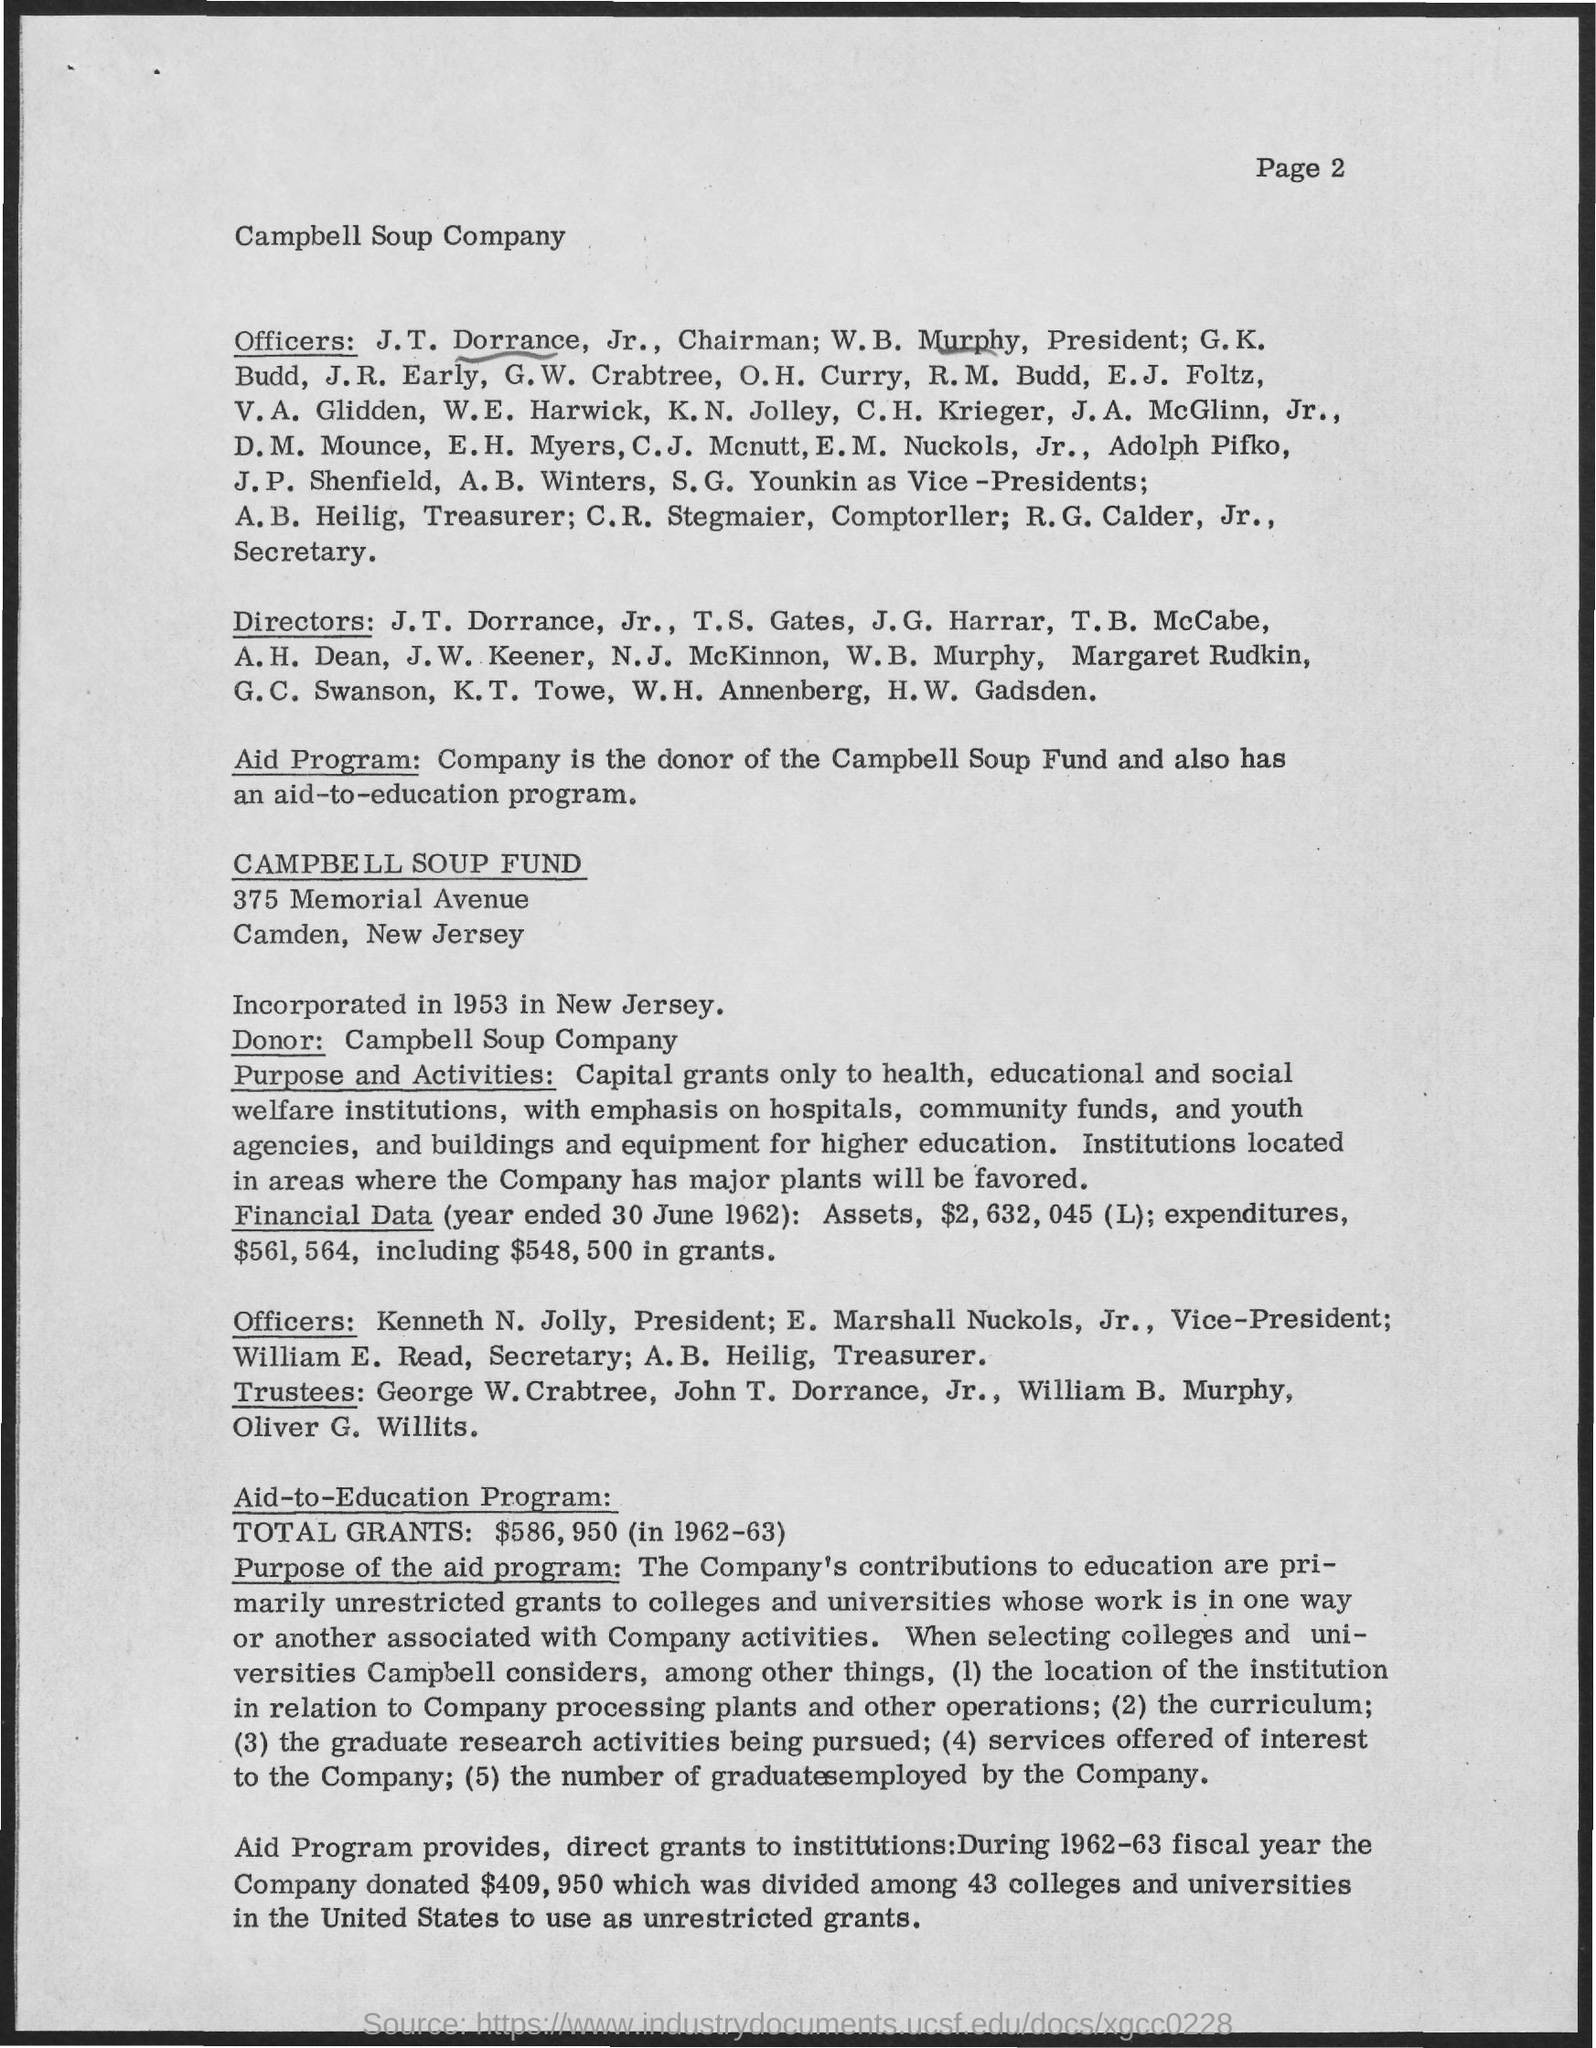Specify some key components in this picture. Campbell Soup Company is mentioned. The Campbell Soup Company is the donor. In 1962-63, the total amount of grants was $586,950. The Campbell Soup Company was incorporated in the state of New Jersey. The Campbell Soup Fund was incorporated in 1953. 